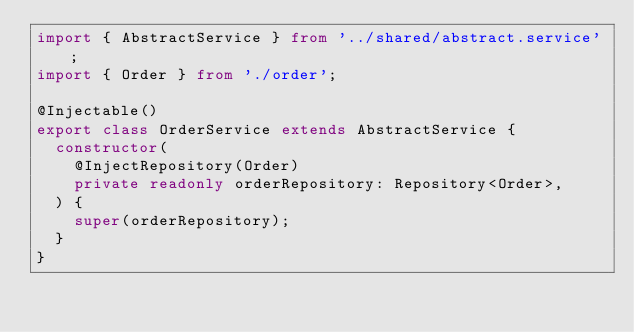Convert code to text. <code><loc_0><loc_0><loc_500><loc_500><_TypeScript_>import { AbstractService } from '../shared/abstract.service';
import { Order } from './order';

@Injectable()
export class OrderService extends AbstractService {
  constructor(
    @InjectRepository(Order)
    private readonly orderRepository: Repository<Order>,
  ) {
    super(orderRepository);
  }
}
</code> 